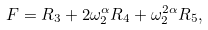<formula> <loc_0><loc_0><loc_500><loc_500>F = R _ { 3 } + 2 \omega _ { 2 } ^ { \alpha } R _ { 4 } + \omega _ { 2 } ^ { 2 \alpha } R _ { 5 } ,</formula> 